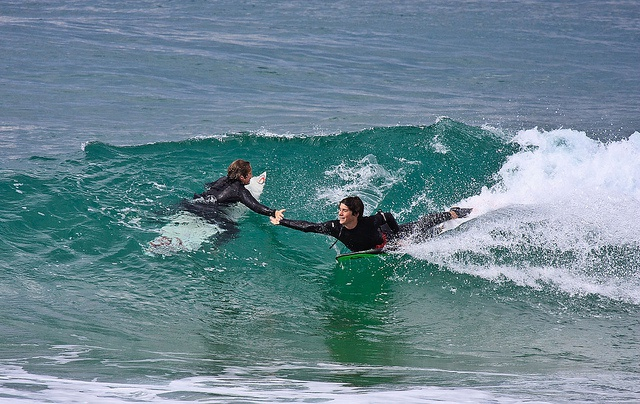Describe the objects in this image and their specific colors. I can see people in gray, black, darkgray, and maroon tones, people in gray, black, and teal tones, surfboard in gray, darkgray, lightblue, and lightgray tones, and surfboard in gray, lavender, darkgray, and black tones in this image. 